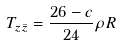Convert formula to latex. <formula><loc_0><loc_0><loc_500><loc_500>T _ { z \bar { z } } = \frac { 2 6 - c } { 2 4 } \rho R</formula> 